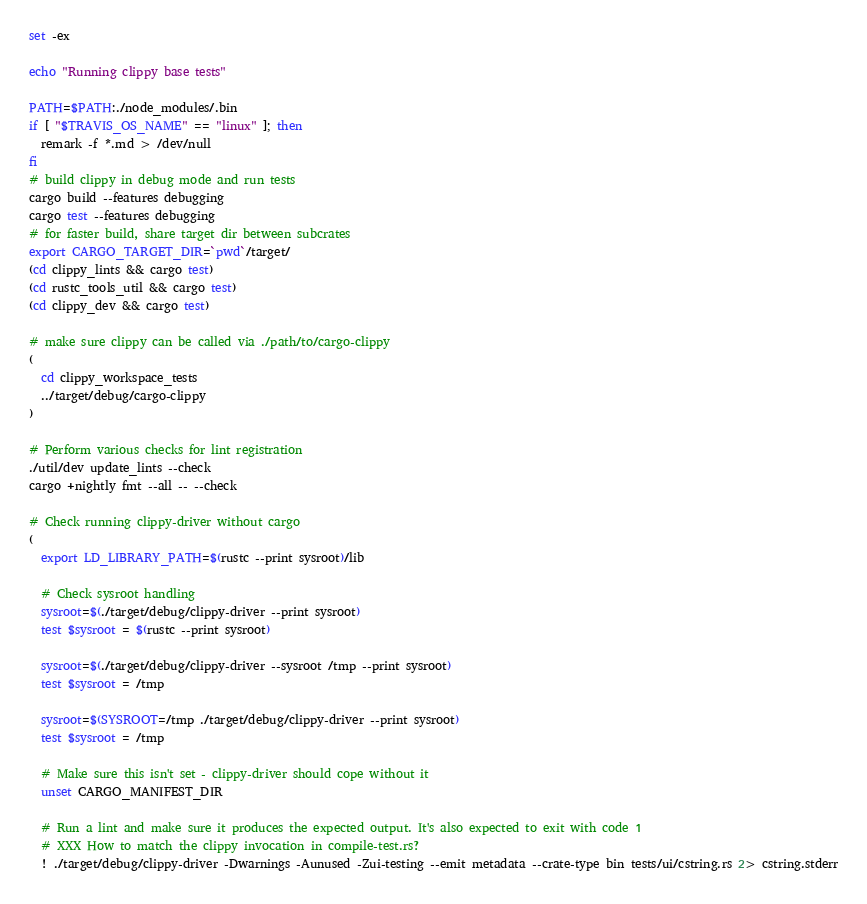<code> <loc_0><loc_0><loc_500><loc_500><_Bash_>set -ex

echo "Running clippy base tests"

PATH=$PATH:./node_modules/.bin
if [ "$TRAVIS_OS_NAME" == "linux" ]; then
  remark -f *.md > /dev/null
fi
# build clippy in debug mode and run tests
cargo build --features debugging
cargo test --features debugging
# for faster build, share target dir between subcrates
export CARGO_TARGET_DIR=`pwd`/target/
(cd clippy_lints && cargo test)
(cd rustc_tools_util && cargo test)
(cd clippy_dev && cargo test)

# make sure clippy can be called via ./path/to/cargo-clippy
(
  cd clippy_workspace_tests
  ../target/debug/cargo-clippy
)

# Perform various checks for lint registration
./util/dev update_lints --check
cargo +nightly fmt --all -- --check

# Check running clippy-driver without cargo
(
  export LD_LIBRARY_PATH=$(rustc --print sysroot)/lib

  # Check sysroot handling
  sysroot=$(./target/debug/clippy-driver --print sysroot)
  test $sysroot = $(rustc --print sysroot)

  sysroot=$(./target/debug/clippy-driver --sysroot /tmp --print sysroot)
  test $sysroot = /tmp

  sysroot=$(SYSROOT=/tmp ./target/debug/clippy-driver --print sysroot)
  test $sysroot = /tmp

  # Make sure this isn't set - clippy-driver should cope without it
  unset CARGO_MANIFEST_DIR

  # Run a lint and make sure it produces the expected output. It's also expected to exit with code 1
  # XXX How to match the clippy invocation in compile-test.rs?
  ! ./target/debug/clippy-driver -Dwarnings -Aunused -Zui-testing --emit metadata --crate-type bin tests/ui/cstring.rs 2> cstring.stderr</code> 